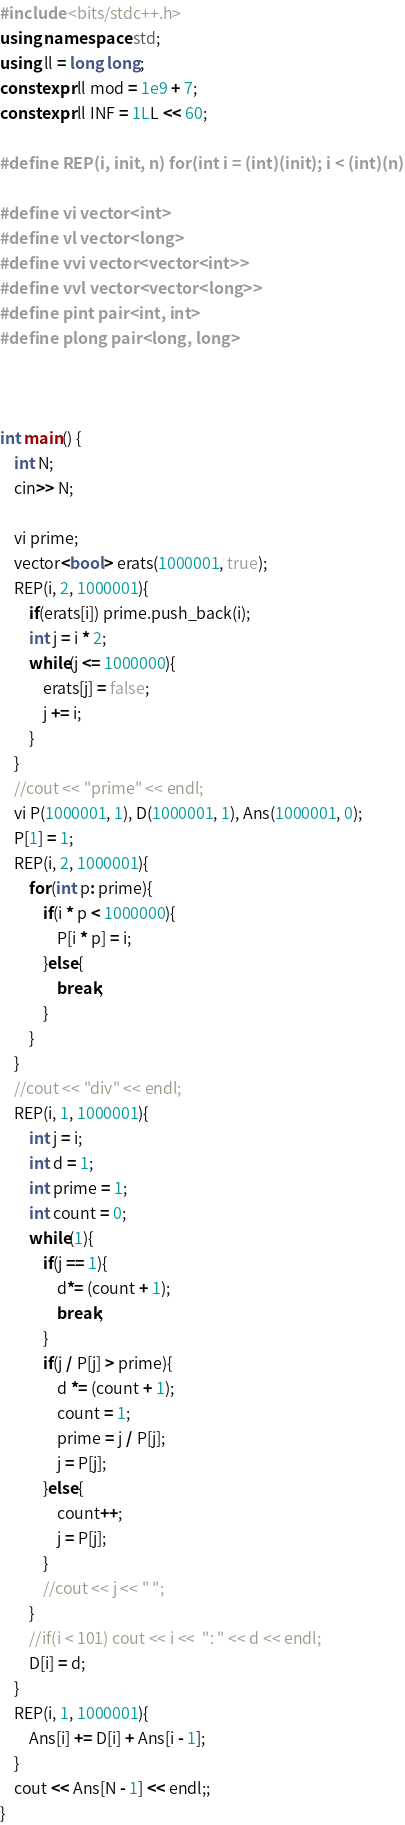Convert code to text. <code><loc_0><loc_0><loc_500><loc_500><_C++_>#include <bits/stdc++.h>
using namespace std;
using ll = long long;
constexpr ll mod = 1e9 + 7;
constexpr ll INF = 1LL << 60;

#define REP(i, init, n) for(int i = (int)(init); i < (int)(n); i++)

#define vi vector<int>
#define vl vector<long>
#define vvi vector<vector<int>>
#define vvl vector<vector<long>>
#define pint pair<int, int>
#define plong pair<long, long>



int main() {
    int N; 
    cin>> N;

    vi prime;
    vector<bool> erats(1000001, true);
    REP(i, 2, 1000001){
        if(erats[i]) prime.push_back(i);
        int j = i * 2;
        while(j <= 1000000){
            erats[j] = false;
            j += i;
        }
    }
    //cout << "prime" << endl;
    vi P(1000001, 1), D(1000001, 1), Ans(1000001, 0);
    P[1] = 1;
    REP(i, 2, 1000001){
        for(int p: prime){
            if(i * p < 1000000){
                P[i * p] = i;
            }else{
                break;
            }
        }
    }
    //cout << "div" << endl;
    REP(i, 1, 1000001){
        int j = i;
        int d = 1;
        int prime = 1;
        int count = 0;
        while(1){
            if(j == 1){
                d*= (count + 1);
                break;
            }
            if(j / P[j] > prime){
                d *= (count + 1);
                count = 1;
                prime = j / P[j];
                j = P[j];
            }else{
                count++;
                j = P[j];
            }
            //cout << j << " ";
        }
        //if(i < 101) cout << i <<  ": " << d << endl;
        D[i] = d;
    }
    REP(i, 1, 1000001){
        Ans[i] += D[i] + Ans[i - 1];
    }
    cout << Ans[N - 1] << endl;;
}</code> 